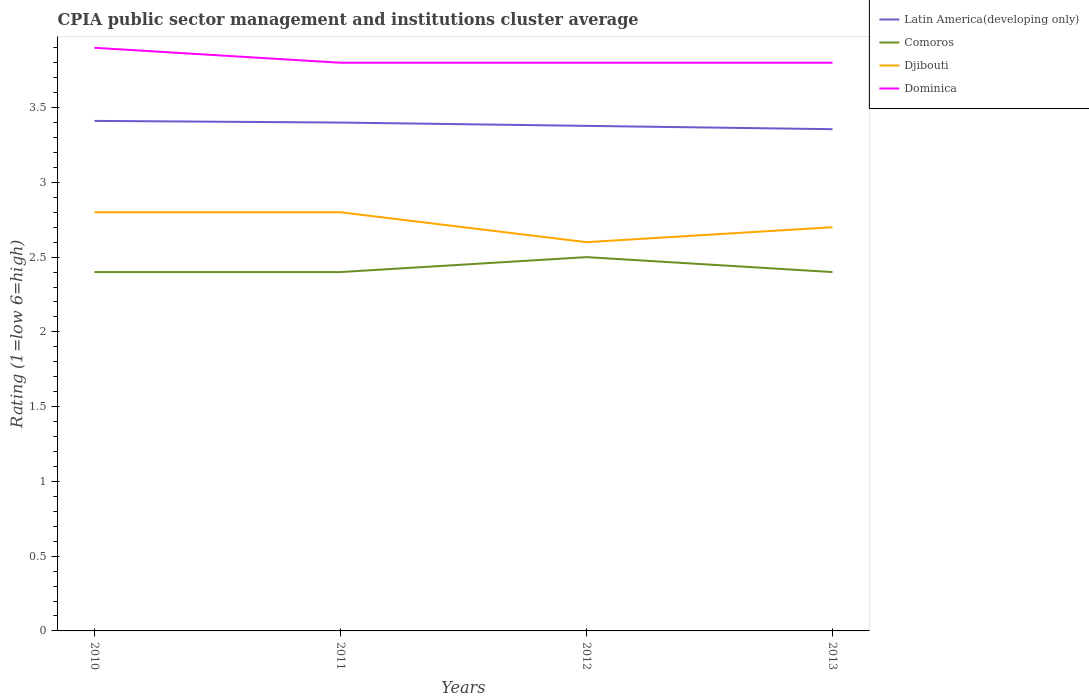How many different coloured lines are there?
Ensure brevity in your answer.  4. Is the number of lines equal to the number of legend labels?
Provide a succinct answer. Yes. In which year was the CPIA rating in Comoros maximum?
Offer a terse response. 2010. What is the total CPIA rating in Djibouti in the graph?
Your answer should be very brief. -0.1. What is the difference between the highest and the second highest CPIA rating in Dominica?
Keep it short and to the point. 0.1. What is the difference between the highest and the lowest CPIA rating in Comoros?
Offer a terse response. 1. Is the CPIA rating in Comoros strictly greater than the CPIA rating in Latin America(developing only) over the years?
Provide a short and direct response. Yes. How many lines are there?
Offer a very short reply. 4. How many years are there in the graph?
Your answer should be very brief. 4. Are the values on the major ticks of Y-axis written in scientific E-notation?
Make the answer very short. No. Does the graph contain any zero values?
Provide a succinct answer. No. Where does the legend appear in the graph?
Make the answer very short. Top right. What is the title of the graph?
Your answer should be very brief. CPIA public sector management and institutions cluster average. Does "Iran" appear as one of the legend labels in the graph?
Your answer should be compact. No. What is the label or title of the X-axis?
Your answer should be very brief. Years. What is the Rating (1=low 6=high) in Latin America(developing only) in 2010?
Your response must be concise. 3.41. What is the Rating (1=low 6=high) of Comoros in 2010?
Make the answer very short. 2.4. What is the Rating (1=low 6=high) in Dominica in 2010?
Your response must be concise. 3.9. What is the Rating (1=low 6=high) in Djibouti in 2011?
Offer a very short reply. 2.8. What is the Rating (1=low 6=high) of Latin America(developing only) in 2012?
Give a very brief answer. 3.38. What is the Rating (1=low 6=high) of Dominica in 2012?
Offer a terse response. 3.8. What is the Rating (1=low 6=high) in Latin America(developing only) in 2013?
Offer a terse response. 3.36. What is the Rating (1=low 6=high) in Comoros in 2013?
Ensure brevity in your answer.  2.4. What is the Rating (1=low 6=high) of Djibouti in 2013?
Offer a terse response. 2.7. Across all years, what is the maximum Rating (1=low 6=high) in Latin America(developing only)?
Provide a succinct answer. 3.41. Across all years, what is the minimum Rating (1=low 6=high) in Latin America(developing only)?
Offer a terse response. 3.36. Across all years, what is the minimum Rating (1=low 6=high) of Djibouti?
Your answer should be compact. 2.6. What is the total Rating (1=low 6=high) in Latin America(developing only) in the graph?
Offer a very short reply. 13.54. What is the total Rating (1=low 6=high) in Dominica in the graph?
Ensure brevity in your answer.  15.3. What is the difference between the Rating (1=low 6=high) of Latin America(developing only) in 2010 and that in 2011?
Your response must be concise. 0.01. What is the difference between the Rating (1=low 6=high) in Comoros in 2010 and that in 2011?
Offer a very short reply. 0. What is the difference between the Rating (1=low 6=high) of Djibouti in 2010 and that in 2011?
Your response must be concise. 0. What is the difference between the Rating (1=low 6=high) of Latin America(developing only) in 2010 and that in 2012?
Keep it short and to the point. 0.03. What is the difference between the Rating (1=low 6=high) of Comoros in 2010 and that in 2012?
Your response must be concise. -0.1. What is the difference between the Rating (1=low 6=high) of Djibouti in 2010 and that in 2012?
Provide a succinct answer. 0.2. What is the difference between the Rating (1=low 6=high) in Latin America(developing only) in 2010 and that in 2013?
Give a very brief answer. 0.06. What is the difference between the Rating (1=low 6=high) of Dominica in 2010 and that in 2013?
Your answer should be very brief. 0.1. What is the difference between the Rating (1=low 6=high) of Latin America(developing only) in 2011 and that in 2012?
Provide a short and direct response. 0.02. What is the difference between the Rating (1=low 6=high) in Comoros in 2011 and that in 2012?
Offer a terse response. -0.1. What is the difference between the Rating (1=low 6=high) of Djibouti in 2011 and that in 2012?
Your response must be concise. 0.2. What is the difference between the Rating (1=low 6=high) in Dominica in 2011 and that in 2012?
Give a very brief answer. 0. What is the difference between the Rating (1=low 6=high) of Latin America(developing only) in 2011 and that in 2013?
Your answer should be very brief. 0.04. What is the difference between the Rating (1=low 6=high) in Latin America(developing only) in 2012 and that in 2013?
Offer a terse response. 0.02. What is the difference between the Rating (1=low 6=high) in Djibouti in 2012 and that in 2013?
Give a very brief answer. -0.1. What is the difference between the Rating (1=low 6=high) in Dominica in 2012 and that in 2013?
Your response must be concise. 0. What is the difference between the Rating (1=low 6=high) of Latin America(developing only) in 2010 and the Rating (1=low 6=high) of Comoros in 2011?
Your answer should be very brief. 1.01. What is the difference between the Rating (1=low 6=high) in Latin America(developing only) in 2010 and the Rating (1=low 6=high) in Djibouti in 2011?
Make the answer very short. 0.61. What is the difference between the Rating (1=low 6=high) of Latin America(developing only) in 2010 and the Rating (1=low 6=high) of Dominica in 2011?
Keep it short and to the point. -0.39. What is the difference between the Rating (1=low 6=high) in Djibouti in 2010 and the Rating (1=low 6=high) in Dominica in 2011?
Offer a very short reply. -1. What is the difference between the Rating (1=low 6=high) in Latin America(developing only) in 2010 and the Rating (1=low 6=high) in Comoros in 2012?
Ensure brevity in your answer.  0.91. What is the difference between the Rating (1=low 6=high) in Latin America(developing only) in 2010 and the Rating (1=low 6=high) in Djibouti in 2012?
Make the answer very short. 0.81. What is the difference between the Rating (1=low 6=high) of Latin America(developing only) in 2010 and the Rating (1=low 6=high) of Dominica in 2012?
Provide a short and direct response. -0.39. What is the difference between the Rating (1=low 6=high) of Djibouti in 2010 and the Rating (1=low 6=high) of Dominica in 2012?
Give a very brief answer. -1. What is the difference between the Rating (1=low 6=high) of Latin America(developing only) in 2010 and the Rating (1=low 6=high) of Comoros in 2013?
Provide a succinct answer. 1.01. What is the difference between the Rating (1=low 6=high) of Latin America(developing only) in 2010 and the Rating (1=low 6=high) of Djibouti in 2013?
Make the answer very short. 0.71. What is the difference between the Rating (1=low 6=high) in Latin America(developing only) in 2010 and the Rating (1=low 6=high) in Dominica in 2013?
Give a very brief answer. -0.39. What is the difference between the Rating (1=low 6=high) in Comoros in 2010 and the Rating (1=low 6=high) in Djibouti in 2013?
Provide a short and direct response. -0.3. What is the difference between the Rating (1=low 6=high) of Djibouti in 2010 and the Rating (1=low 6=high) of Dominica in 2013?
Provide a succinct answer. -1. What is the difference between the Rating (1=low 6=high) in Latin America(developing only) in 2011 and the Rating (1=low 6=high) in Djibouti in 2012?
Keep it short and to the point. 0.8. What is the difference between the Rating (1=low 6=high) in Latin America(developing only) in 2011 and the Rating (1=low 6=high) in Dominica in 2012?
Give a very brief answer. -0.4. What is the difference between the Rating (1=low 6=high) in Comoros in 2011 and the Rating (1=low 6=high) in Djibouti in 2012?
Make the answer very short. -0.2. What is the difference between the Rating (1=low 6=high) in Comoros in 2011 and the Rating (1=low 6=high) in Dominica in 2012?
Make the answer very short. -1.4. What is the difference between the Rating (1=low 6=high) of Latin America(developing only) in 2011 and the Rating (1=low 6=high) of Djibouti in 2013?
Ensure brevity in your answer.  0.7. What is the difference between the Rating (1=low 6=high) in Latin America(developing only) in 2012 and the Rating (1=low 6=high) in Comoros in 2013?
Your answer should be compact. 0.98. What is the difference between the Rating (1=low 6=high) of Latin America(developing only) in 2012 and the Rating (1=low 6=high) of Djibouti in 2013?
Your answer should be compact. 0.68. What is the difference between the Rating (1=low 6=high) in Latin America(developing only) in 2012 and the Rating (1=low 6=high) in Dominica in 2013?
Your response must be concise. -0.42. What is the difference between the Rating (1=low 6=high) in Comoros in 2012 and the Rating (1=low 6=high) in Dominica in 2013?
Offer a terse response. -1.3. What is the difference between the Rating (1=low 6=high) of Djibouti in 2012 and the Rating (1=low 6=high) of Dominica in 2013?
Provide a short and direct response. -1.2. What is the average Rating (1=low 6=high) of Latin America(developing only) per year?
Your response must be concise. 3.39. What is the average Rating (1=low 6=high) of Comoros per year?
Offer a terse response. 2.42. What is the average Rating (1=low 6=high) of Djibouti per year?
Keep it short and to the point. 2.73. What is the average Rating (1=low 6=high) in Dominica per year?
Make the answer very short. 3.83. In the year 2010, what is the difference between the Rating (1=low 6=high) of Latin America(developing only) and Rating (1=low 6=high) of Comoros?
Ensure brevity in your answer.  1.01. In the year 2010, what is the difference between the Rating (1=low 6=high) of Latin America(developing only) and Rating (1=low 6=high) of Djibouti?
Offer a very short reply. 0.61. In the year 2010, what is the difference between the Rating (1=low 6=high) in Latin America(developing only) and Rating (1=low 6=high) in Dominica?
Your response must be concise. -0.49. In the year 2011, what is the difference between the Rating (1=low 6=high) of Latin America(developing only) and Rating (1=low 6=high) of Djibouti?
Ensure brevity in your answer.  0.6. In the year 2011, what is the difference between the Rating (1=low 6=high) of Latin America(developing only) and Rating (1=low 6=high) of Dominica?
Offer a terse response. -0.4. In the year 2011, what is the difference between the Rating (1=low 6=high) in Comoros and Rating (1=low 6=high) in Djibouti?
Your response must be concise. -0.4. In the year 2012, what is the difference between the Rating (1=low 6=high) of Latin America(developing only) and Rating (1=low 6=high) of Comoros?
Provide a short and direct response. 0.88. In the year 2012, what is the difference between the Rating (1=low 6=high) of Latin America(developing only) and Rating (1=low 6=high) of Dominica?
Make the answer very short. -0.42. In the year 2012, what is the difference between the Rating (1=low 6=high) of Djibouti and Rating (1=low 6=high) of Dominica?
Keep it short and to the point. -1.2. In the year 2013, what is the difference between the Rating (1=low 6=high) of Latin America(developing only) and Rating (1=low 6=high) of Comoros?
Give a very brief answer. 0.96. In the year 2013, what is the difference between the Rating (1=low 6=high) of Latin America(developing only) and Rating (1=low 6=high) of Djibouti?
Keep it short and to the point. 0.66. In the year 2013, what is the difference between the Rating (1=low 6=high) of Latin America(developing only) and Rating (1=low 6=high) of Dominica?
Offer a very short reply. -0.44. In the year 2013, what is the difference between the Rating (1=low 6=high) of Comoros and Rating (1=low 6=high) of Djibouti?
Offer a terse response. -0.3. In the year 2013, what is the difference between the Rating (1=low 6=high) in Comoros and Rating (1=low 6=high) in Dominica?
Your answer should be compact. -1.4. What is the ratio of the Rating (1=low 6=high) in Latin America(developing only) in 2010 to that in 2011?
Offer a terse response. 1. What is the ratio of the Rating (1=low 6=high) in Djibouti in 2010 to that in 2011?
Offer a very short reply. 1. What is the ratio of the Rating (1=low 6=high) of Dominica in 2010 to that in 2011?
Offer a very short reply. 1.03. What is the ratio of the Rating (1=low 6=high) of Latin America(developing only) in 2010 to that in 2012?
Ensure brevity in your answer.  1.01. What is the ratio of the Rating (1=low 6=high) in Comoros in 2010 to that in 2012?
Provide a succinct answer. 0.96. What is the ratio of the Rating (1=low 6=high) of Djibouti in 2010 to that in 2012?
Ensure brevity in your answer.  1.08. What is the ratio of the Rating (1=low 6=high) of Dominica in 2010 to that in 2012?
Ensure brevity in your answer.  1.03. What is the ratio of the Rating (1=low 6=high) of Latin America(developing only) in 2010 to that in 2013?
Provide a short and direct response. 1.02. What is the ratio of the Rating (1=low 6=high) of Dominica in 2010 to that in 2013?
Provide a succinct answer. 1.03. What is the ratio of the Rating (1=low 6=high) in Latin America(developing only) in 2011 to that in 2012?
Ensure brevity in your answer.  1.01. What is the ratio of the Rating (1=low 6=high) in Comoros in 2011 to that in 2012?
Offer a very short reply. 0.96. What is the ratio of the Rating (1=low 6=high) of Djibouti in 2011 to that in 2012?
Offer a terse response. 1.08. What is the ratio of the Rating (1=low 6=high) of Dominica in 2011 to that in 2012?
Offer a terse response. 1. What is the ratio of the Rating (1=low 6=high) of Latin America(developing only) in 2011 to that in 2013?
Ensure brevity in your answer.  1.01. What is the ratio of the Rating (1=low 6=high) of Comoros in 2011 to that in 2013?
Your answer should be compact. 1. What is the ratio of the Rating (1=low 6=high) in Latin America(developing only) in 2012 to that in 2013?
Keep it short and to the point. 1.01. What is the ratio of the Rating (1=low 6=high) of Comoros in 2012 to that in 2013?
Make the answer very short. 1.04. What is the ratio of the Rating (1=low 6=high) in Djibouti in 2012 to that in 2013?
Offer a very short reply. 0.96. What is the ratio of the Rating (1=low 6=high) of Dominica in 2012 to that in 2013?
Provide a short and direct response. 1. What is the difference between the highest and the second highest Rating (1=low 6=high) of Latin America(developing only)?
Provide a short and direct response. 0.01. What is the difference between the highest and the second highest Rating (1=low 6=high) of Djibouti?
Your response must be concise. 0. What is the difference between the highest and the lowest Rating (1=low 6=high) in Latin America(developing only)?
Give a very brief answer. 0.06. 